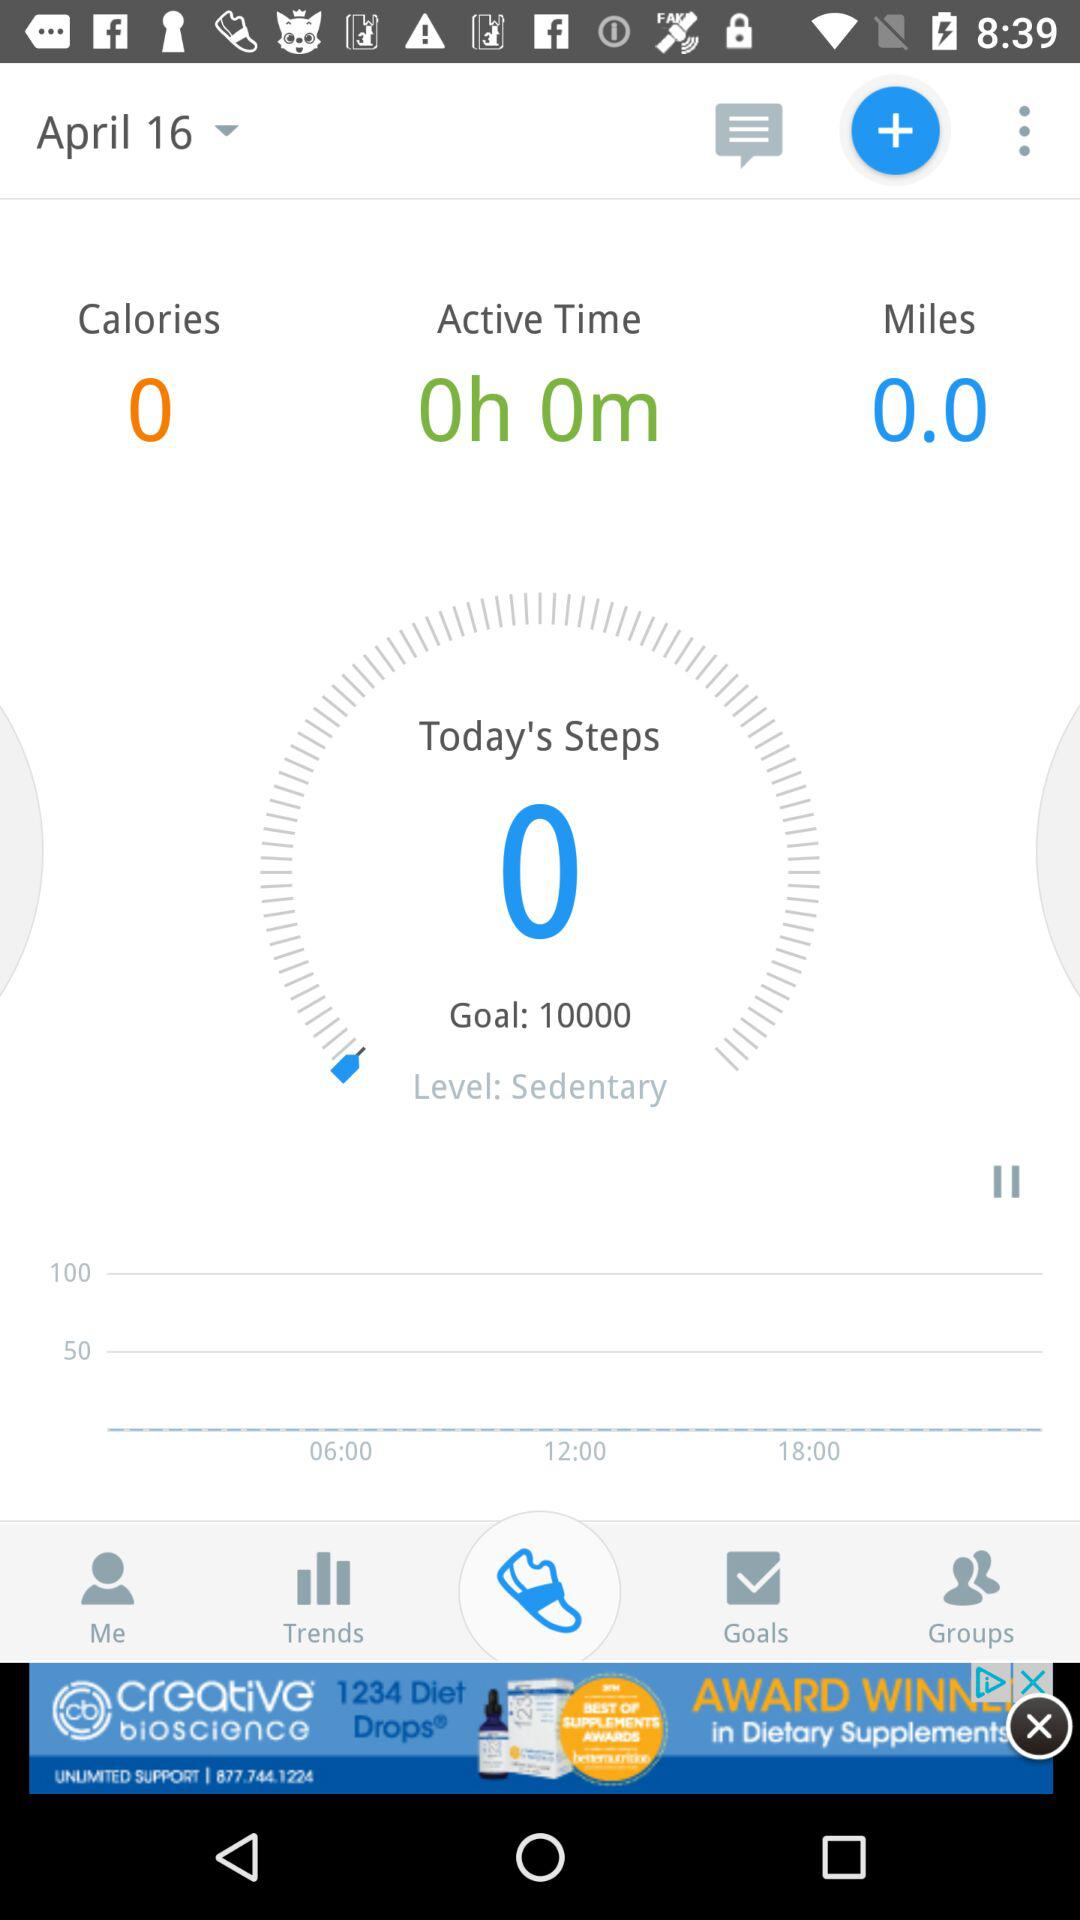How many calories are shown there? There are 0 calories. 